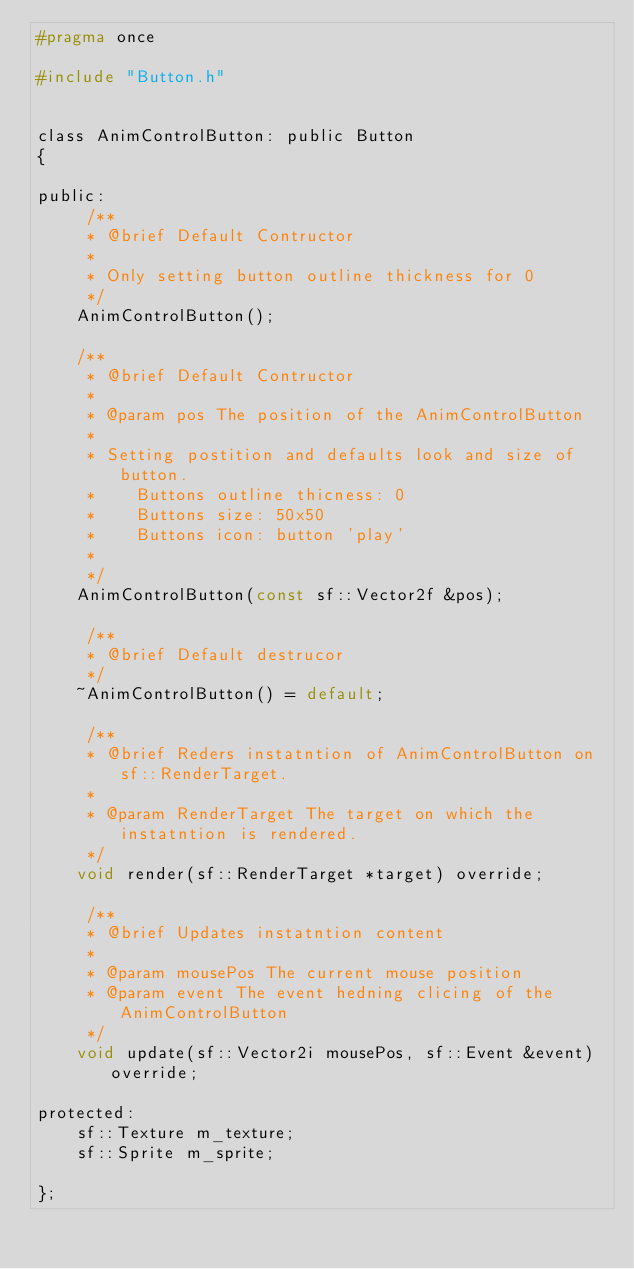Convert code to text. <code><loc_0><loc_0><loc_500><loc_500><_C_>#pragma once

#include "Button.h"


class AnimControlButton: public Button
{

public:
     /**
     * @brief Default Contructor 
     *   
     * Only setting button outline thickness for 0
     */
	AnimControlButton();

    /**
     * @brief Default Contructor
     *
     * @param pos The position of the AnimControlButton
     *
     * Setting postition and defaults look and size of button.
     *    Buttons outline thicness: 0
     *    Buttons size: 50x50
     *    Buttons icon: button 'play'
     *    
     */
	AnimControlButton(const sf::Vector2f &pos);
    
     /**
     * @brief Default destrucor 
     */
	~AnimControlButton() = default;

     /**
     * @brief Reders instatntion of AnimControlButton on sf::RenderTarget.
     *
     * @param RenderTarget The target on which the instatntion is rendered.
     */
	void render(sf::RenderTarget *target) override;

     /**
     * @brief Updates instatntion content
     *
     * @param mousePos The current mouse position 
     * @param event The event hedning clicing of the AnimControlButton 
     */
	void update(sf::Vector2i mousePos, sf::Event &event) override;

protected:
	sf::Texture m_texture;
	sf::Sprite m_sprite;
	
};
</code> 